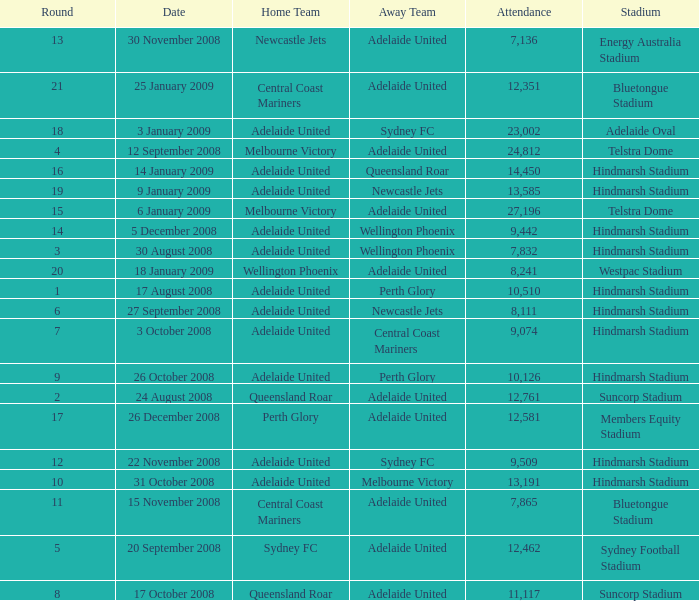What is the round when 11,117 people attended the game on 26 October 2008? 9.0. Write the full table. {'header': ['Round', 'Date', 'Home Team', 'Away Team', 'Attendance', 'Stadium'], 'rows': [['13', '30 November 2008', 'Newcastle Jets', 'Adelaide United', '7,136', 'Energy Australia Stadium'], ['21', '25 January 2009', 'Central Coast Mariners', 'Adelaide United', '12,351', 'Bluetongue Stadium'], ['18', '3 January 2009', 'Adelaide United', 'Sydney FC', '23,002', 'Adelaide Oval'], ['4', '12 September 2008', 'Melbourne Victory', 'Adelaide United', '24,812', 'Telstra Dome'], ['16', '14 January 2009', 'Adelaide United', 'Queensland Roar', '14,450', 'Hindmarsh Stadium'], ['19', '9 January 2009', 'Adelaide United', 'Newcastle Jets', '13,585', 'Hindmarsh Stadium'], ['15', '6 January 2009', 'Melbourne Victory', 'Adelaide United', '27,196', 'Telstra Dome'], ['14', '5 December 2008', 'Adelaide United', 'Wellington Phoenix', '9,442', 'Hindmarsh Stadium'], ['3', '30 August 2008', 'Adelaide United', 'Wellington Phoenix', '7,832', 'Hindmarsh Stadium'], ['20', '18 January 2009', 'Wellington Phoenix', 'Adelaide United', '8,241', 'Westpac Stadium'], ['1', '17 August 2008', 'Adelaide United', 'Perth Glory', '10,510', 'Hindmarsh Stadium'], ['6', '27 September 2008', 'Adelaide United', 'Newcastle Jets', '8,111', 'Hindmarsh Stadium'], ['7', '3 October 2008', 'Adelaide United', 'Central Coast Mariners', '9,074', 'Hindmarsh Stadium'], ['9', '26 October 2008', 'Adelaide United', 'Perth Glory', '10,126', 'Hindmarsh Stadium'], ['2', '24 August 2008', 'Queensland Roar', 'Adelaide United', '12,761', 'Suncorp Stadium'], ['17', '26 December 2008', 'Perth Glory', 'Adelaide United', '12,581', 'Members Equity Stadium'], ['12', '22 November 2008', 'Adelaide United', 'Sydney FC', '9,509', 'Hindmarsh Stadium'], ['10', '31 October 2008', 'Adelaide United', 'Melbourne Victory', '13,191', 'Hindmarsh Stadium'], ['11', '15 November 2008', 'Central Coast Mariners', 'Adelaide United', '7,865', 'Bluetongue Stadium'], ['5', '20 September 2008', 'Sydney FC', 'Adelaide United', '12,462', 'Sydney Football Stadium'], ['8', '17 October 2008', 'Queensland Roar', 'Adelaide United', '11,117', 'Suncorp Stadium']]} 